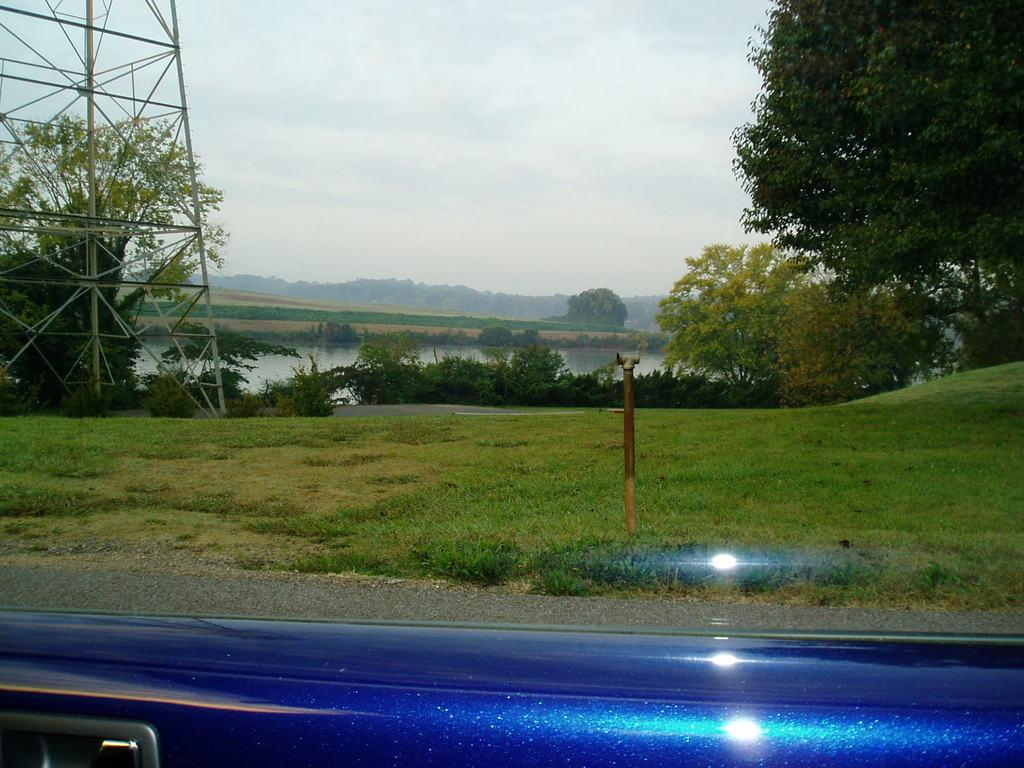What is the perspective of the image? The image is taken from a vehicle. What type of vegetation can be seen in the image? There are trees and plants in the image. What type of structure is visible in the image? There is a tower in the image. What is on the ground in the image? There is grass on the ground in the image. What is the condition of the sky in the image? The sky is cloudy in the image. What type of popcorn is being served in the image? There is no popcorn present in the image. What type of wine is being consumed in the image? There is no wine present in the image. 